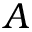<formula> <loc_0><loc_0><loc_500><loc_500>A</formula> 